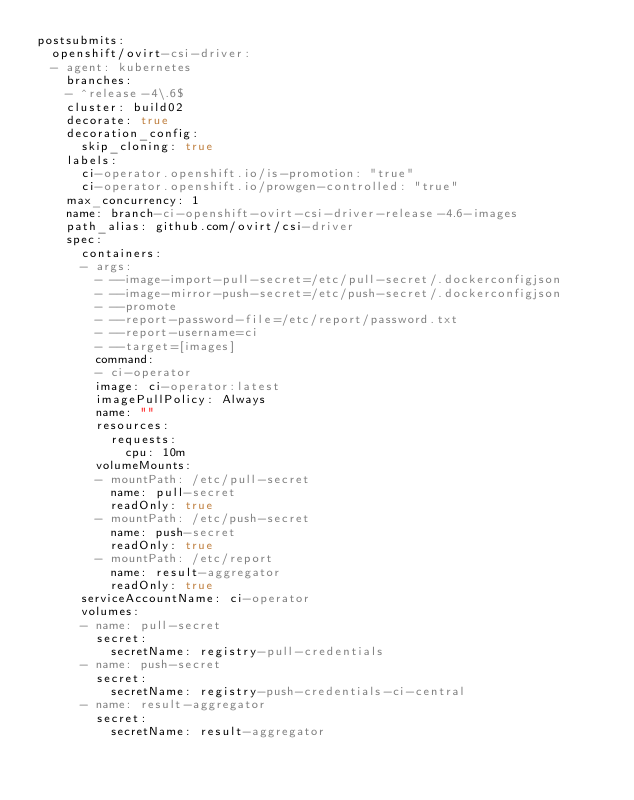<code> <loc_0><loc_0><loc_500><loc_500><_YAML_>postsubmits:
  openshift/ovirt-csi-driver:
  - agent: kubernetes
    branches:
    - ^release-4\.6$
    cluster: build02
    decorate: true
    decoration_config:
      skip_cloning: true
    labels:
      ci-operator.openshift.io/is-promotion: "true"
      ci-operator.openshift.io/prowgen-controlled: "true"
    max_concurrency: 1
    name: branch-ci-openshift-ovirt-csi-driver-release-4.6-images
    path_alias: github.com/ovirt/csi-driver
    spec:
      containers:
      - args:
        - --image-import-pull-secret=/etc/pull-secret/.dockerconfigjson
        - --image-mirror-push-secret=/etc/push-secret/.dockerconfigjson
        - --promote
        - --report-password-file=/etc/report/password.txt
        - --report-username=ci
        - --target=[images]
        command:
        - ci-operator
        image: ci-operator:latest
        imagePullPolicy: Always
        name: ""
        resources:
          requests:
            cpu: 10m
        volumeMounts:
        - mountPath: /etc/pull-secret
          name: pull-secret
          readOnly: true
        - mountPath: /etc/push-secret
          name: push-secret
          readOnly: true
        - mountPath: /etc/report
          name: result-aggregator
          readOnly: true
      serviceAccountName: ci-operator
      volumes:
      - name: pull-secret
        secret:
          secretName: registry-pull-credentials
      - name: push-secret
        secret:
          secretName: registry-push-credentials-ci-central
      - name: result-aggregator
        secret:
          secretName: result-aggregator
</code> 